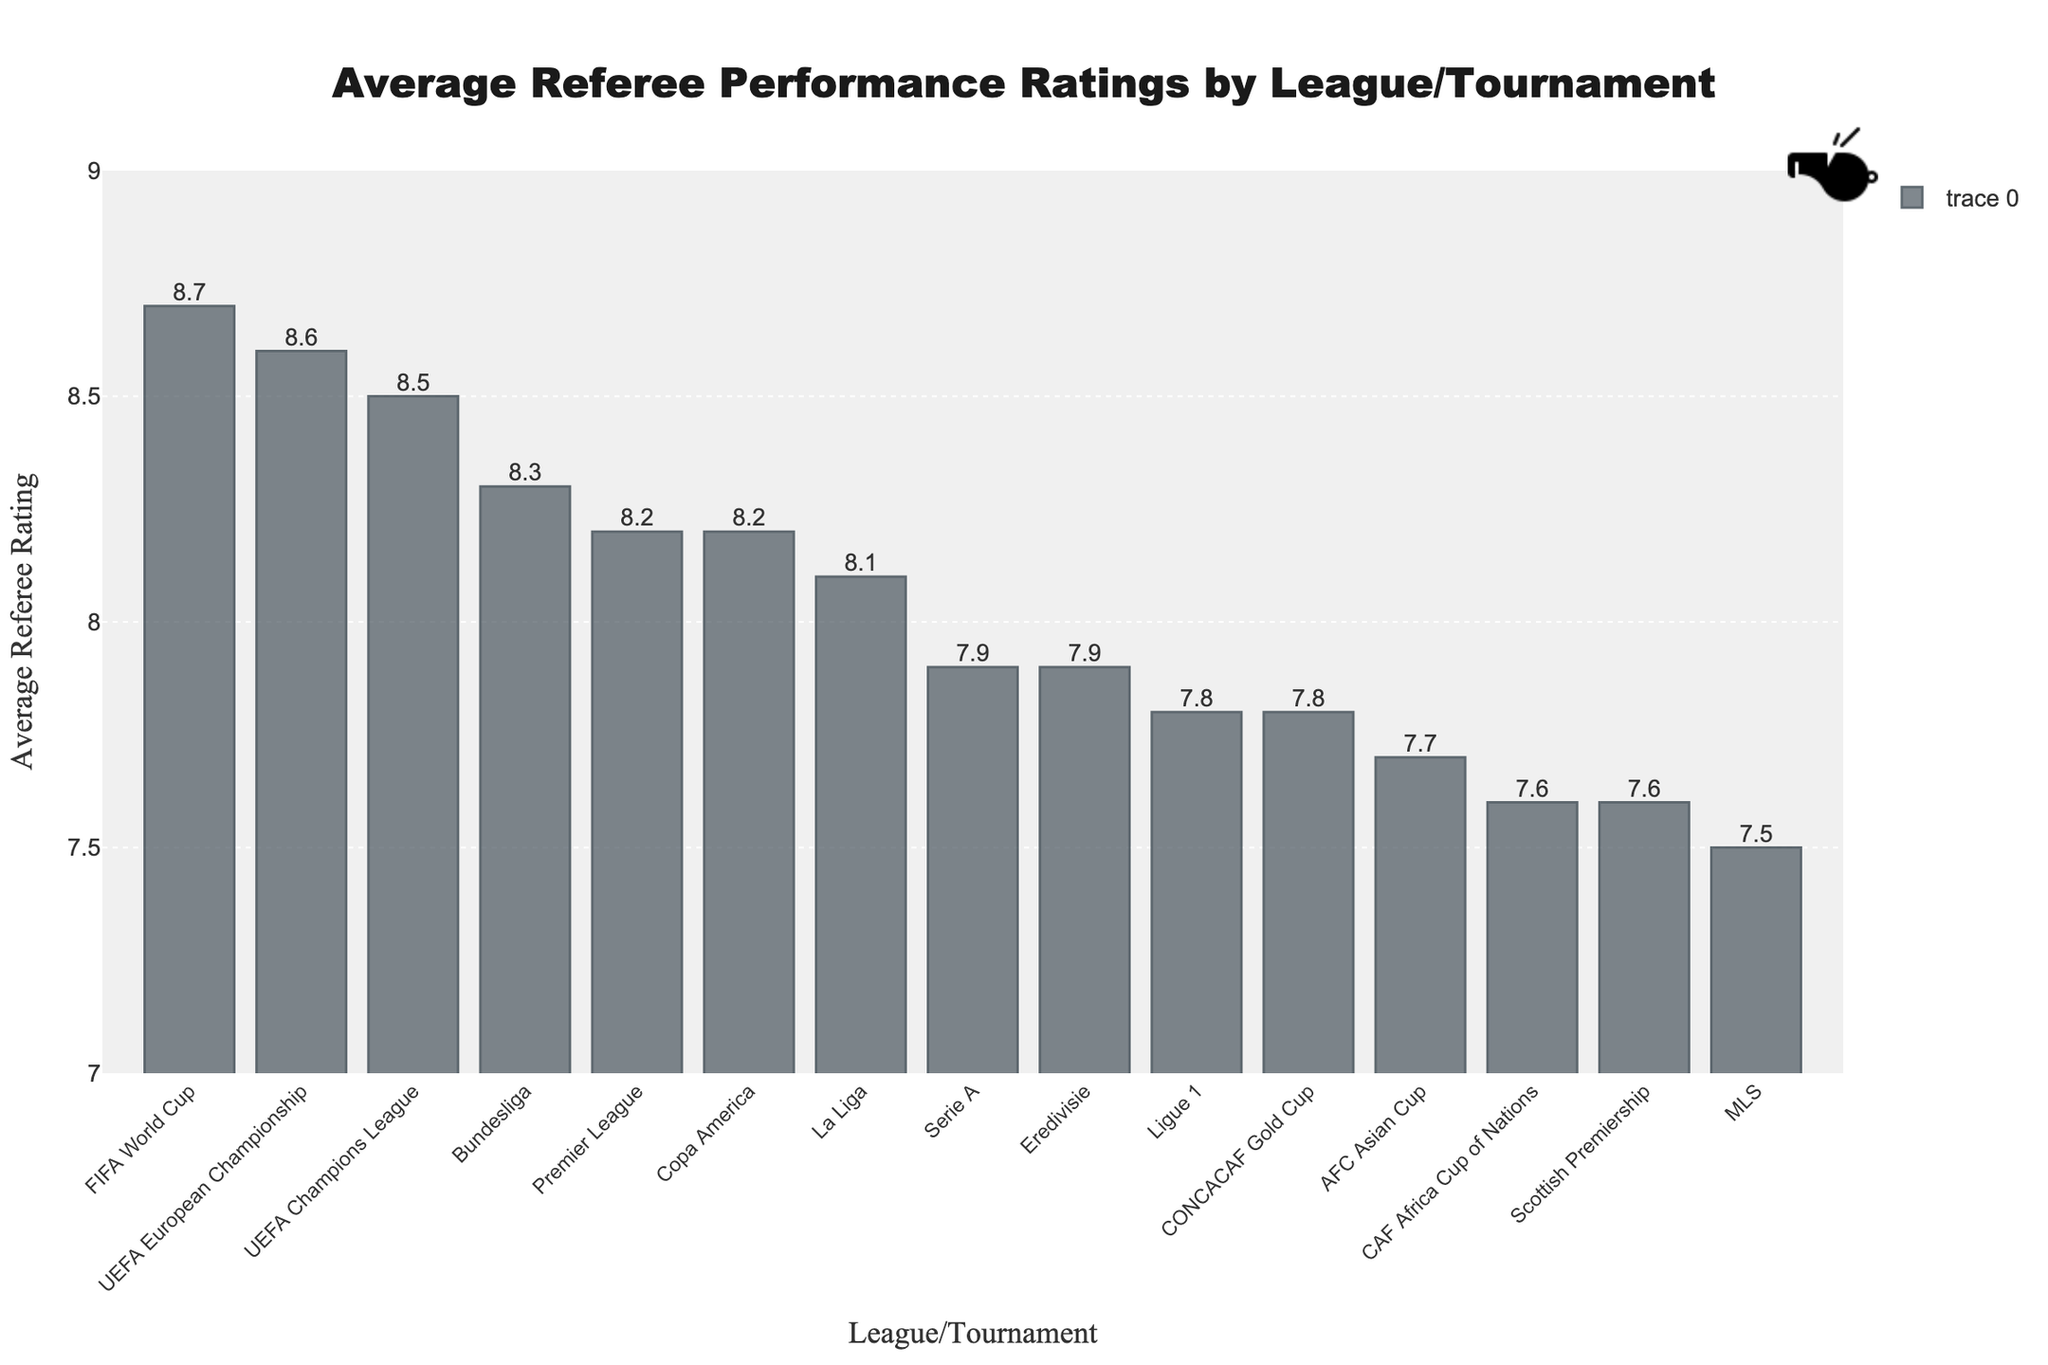Which league/tournament has the highest average referee rating? Look at the bar chart and identify the bar with the highest value. The highest value corresponds to the FIFA World Cup.
Answer: FIFA World Cup How does the average referee rating of the Premier League compare to the Serie A? Locate the bars for Premier League and Serie A. The Premier League's bar reaches 8.2, while the Serie A's bar reaches 7.9.
Answer: Premier League has a higher rating (8.2 vs 7.9) What is the difference between the highest and lowest average referee ratings? Identify the highest rating (FIFA World Cup at 8.7) and the lowest rating (MLS at 7.5). Subtract the lowest from the highest: 8.7 - 7.5 = 1.2.
Answer: 1.2 Which tournaments have average referee ratings of 8.5 or higher? Look at the bars with values greater than or equal to 8.5. These are the UEFA Champions League (8.5), FIFA World Cup (8.7), and UEFA European Championship (8.6).
Answer: UEFA Champions League, FIFA World Cup, UEFA European Championship What is the median average referee rating of all leagues/tournaments? List all ratings: 8.7, 8.6, 8.5, 8.3, 8.2, 8.2, 8.1, 7.9, 7.9, 7.8, 7.8, 7.7, 7.6, 7.6, 7.5. The middle value in this sorted list is 7.9.
Answer: 7.9 By how much does the Bundesliga referee rating exceed the Ligue 1 average referee rating? Identify the ratings for Bundesliga (8.3) and Ligue 1 (7.8). Subtract the latter from the former: 8.3 - 7.8 = 0.5.
Answer: 0.5 Which leagues/tournaments have identical average referee ratings, and what are those ratings? Look for bars with the same height. Premier League and Copa America both have 8.2; Serie A and Eredivisie both have 7.9; Ligue 1 and CONCACAF Gold Cup both have 7.8; Scottish Premiership and CAF Africa Cup of Nations both have 7.6.
Answer: Premier League and Copa America (8.2); Serie A and Eredivisie (7.9); Ligue 1 and CONCACAF Gold Cup (7.8); Scottish Premiership and CAF Africa Cup of Nations (7.6) Which tournament has the third highest average referee rating? Sort and list the ratings in descending order: 8.7, 8.6, 8.5, 8.3, etc. The third highest rating is for UEFA Champions League (8.5).
Answer: UEFA Champions League 